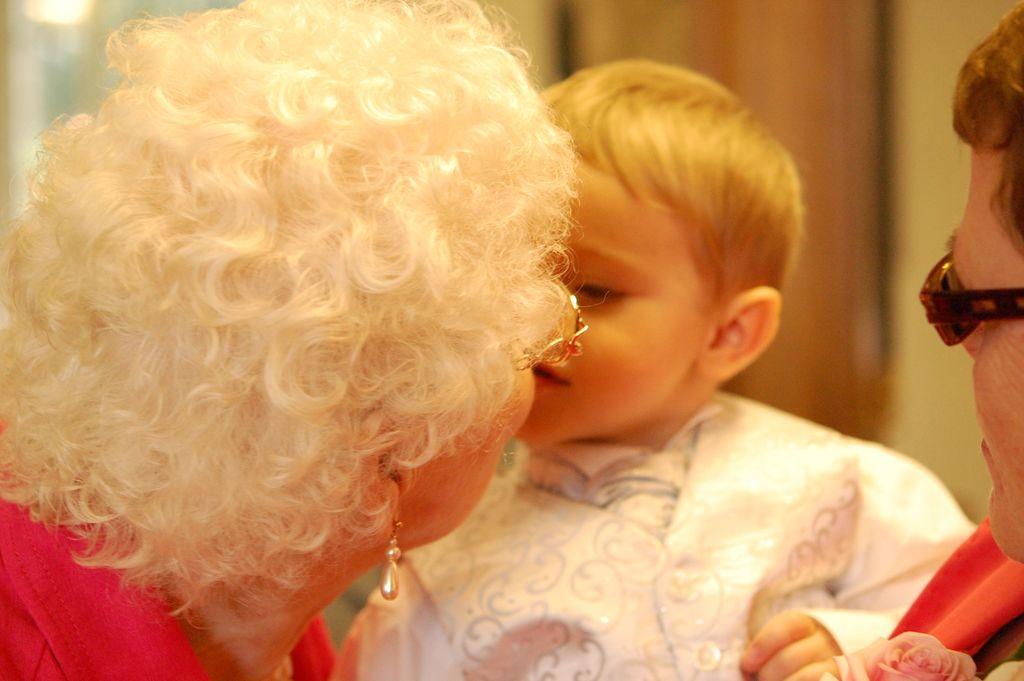Could you give a brief overview of what you see in this image? In this image, we can see an old woman kissing the kid, there is a person standing and holding a kid, there is a blurred background. 